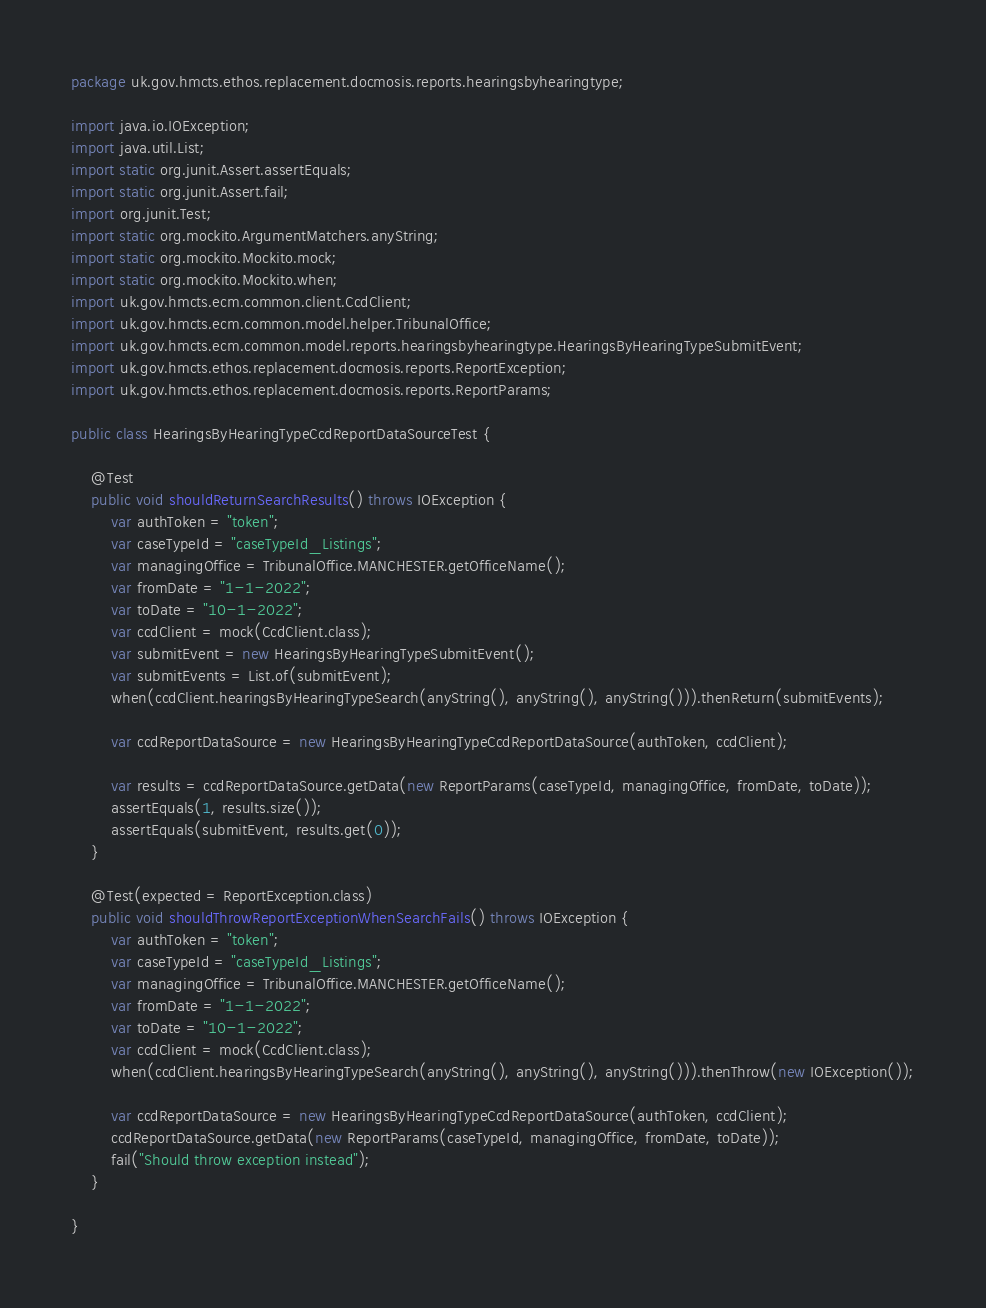<code> <loc_0><loc_0><loc_500><loc_500><_Java_>package uk.gov.hmcts.ethos.replacement.docmosis.reports.hearingsbyhearingtype;

import java.io.IOException;
import java.util.List;
import static org.junit.Assert.assertEquals;
import static org.junit.Assert.fail;
import org.junit.Test;
import static org.mockito.ArgumentMatchers.anyString;
import static org.mockito.Mockito.mock;
import static org.mockito.Mockito.when;
import uk.gov.hmcts.ecm.common.client.CcdClient;
import uk.gov.hmcts.ecm.common.model.helper.TribunalOffice;
import uk.gov.hmcts.ecm.common.model.reports.hearingsbyhearingtype.HearingsByHearingTypeSubmitEvent;
import uk.gov.hmcts.ethos.replacement.docmosis.reports.ReportException;
import uk.gov.hmcts.ethos.replacement.docmosis.reports.ReportParams;

public class HearingsByHearingTypeCcdReportDataSourceTest {

    @Test
    public void shouldReturnSearchResults() throws IOException {
        var authToken = "token";
        var caseTypeId = "caseTypeId_Listings";
        var managingOffice = TribunalOffice.MANCHESTER.getOfficeName();
        var fromDate = "1-1-2022";
        var toDate = "10-1-2022";
        var ccdClient = mock(CcdClient.class);
        var submitEvent = new HearingsByHearingTypeSubmitEvent();
        var submitEvents = List.of(submitEvent);
        when(ccdClient.hearingsByHearingTypeSearch(anyString(), anyString(), anyString())).thenReturn(submitEvents);

        var ccdReportDataSource = new HearingsByHearingTypeCcdReportDataSource(authToken, ccdClient);

        var results = ccdReportDataSource.getData(new ReportParams(caseTypeId, managingOffice, fromDate, toDate));
        assertEquals(1, results.size());
        assertEquals(submitEvent, results.get(0));
    }

    @Test(expected = ReportException.class)
    public void shouldThrowReportExceptionWhenSearchFails() throws IOException {
        var authToken = "token";
        var caseTypeId = "caseTypeId_Listings";
        var managingOffice = TribunalOffice.MANCHESTER.getOfficeName();
        var fromDate = "1-1-2022";
        var toDate = "10-1-2022";
        var ccdClient = mock(CcdClient.class);
        when(ccdClient.hearingsByHearingTypeSearch(anyString(), anyString(), anyString())).thenThrow(new IOException());

        var ccdReportDataSource = new HearingsByHearingTypeCcdReportDataSource(authToken, ccdClient);
        ccdReportDataSource.getData(new ReportParams(caseTypeId, managingOffice, fromDate, toDate));
        fail("Should throw exception instead");
    }

}
</code> 